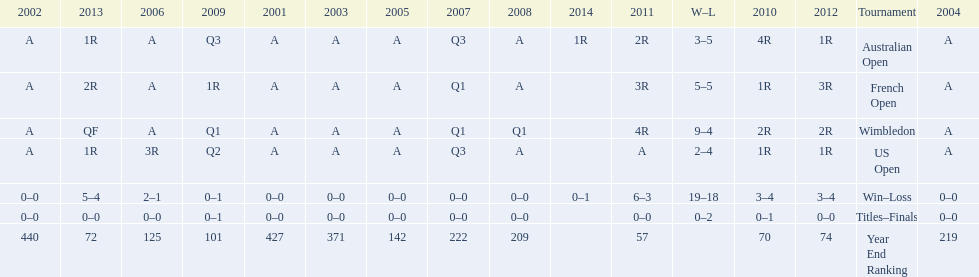What was this players ranking after 2005? 125. 